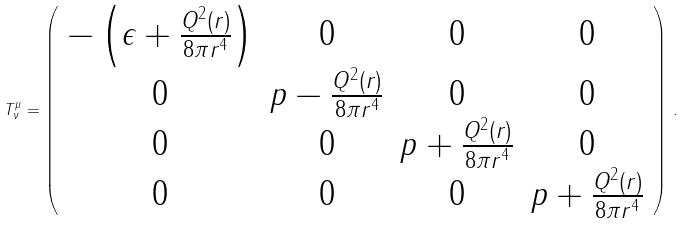Convert formula to latex. <formula><loc_0><loc_0><loc_500><loc_500>T _ { \nu } ^ { \mu } = \left ( \begin{array} { c c c c } - \left ( \epsilon + \frac { Q ^ { 2 } ( r ) } { 8 \pi r ^ { 4 } } \right ) & 0 & 0 & 0 \\ 0 & p - \frac { Q ^ { 2 } ( r ) } { 8 \pi r ^ { 4 } } & 0 & 0 \\ 0 & 0 & p + \frac { Q ^ { 2 } ( r ) } { 8 \pi r ^ { 4 } } & 0 \\ 0 & 0 & 0 & p + \frac { Q ^ { 2 } ( r ) } { 8 \pi r ^ { 4 } } \end{array} \right ) \, .</formula> 